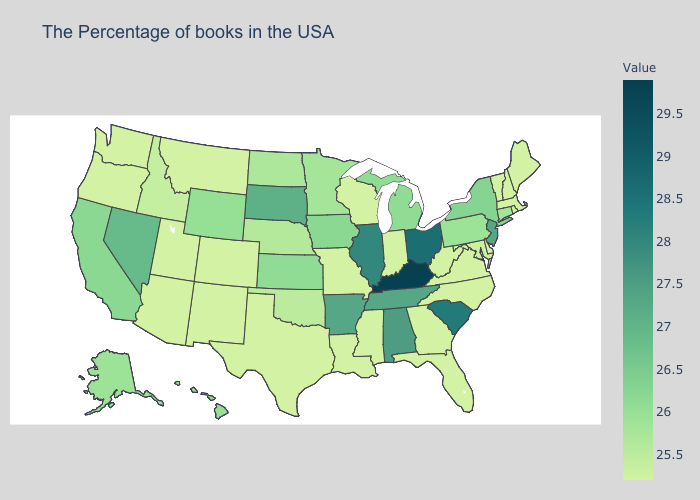Among the states that border Indiana , does Kentucky have the highest value?
Write a very short answer. Yes. Among the states that border California , does Oregon have the lowest value?
Be succinct. Yes. Which states have the highest value in the USA?
Short answer required. Kentucky. 